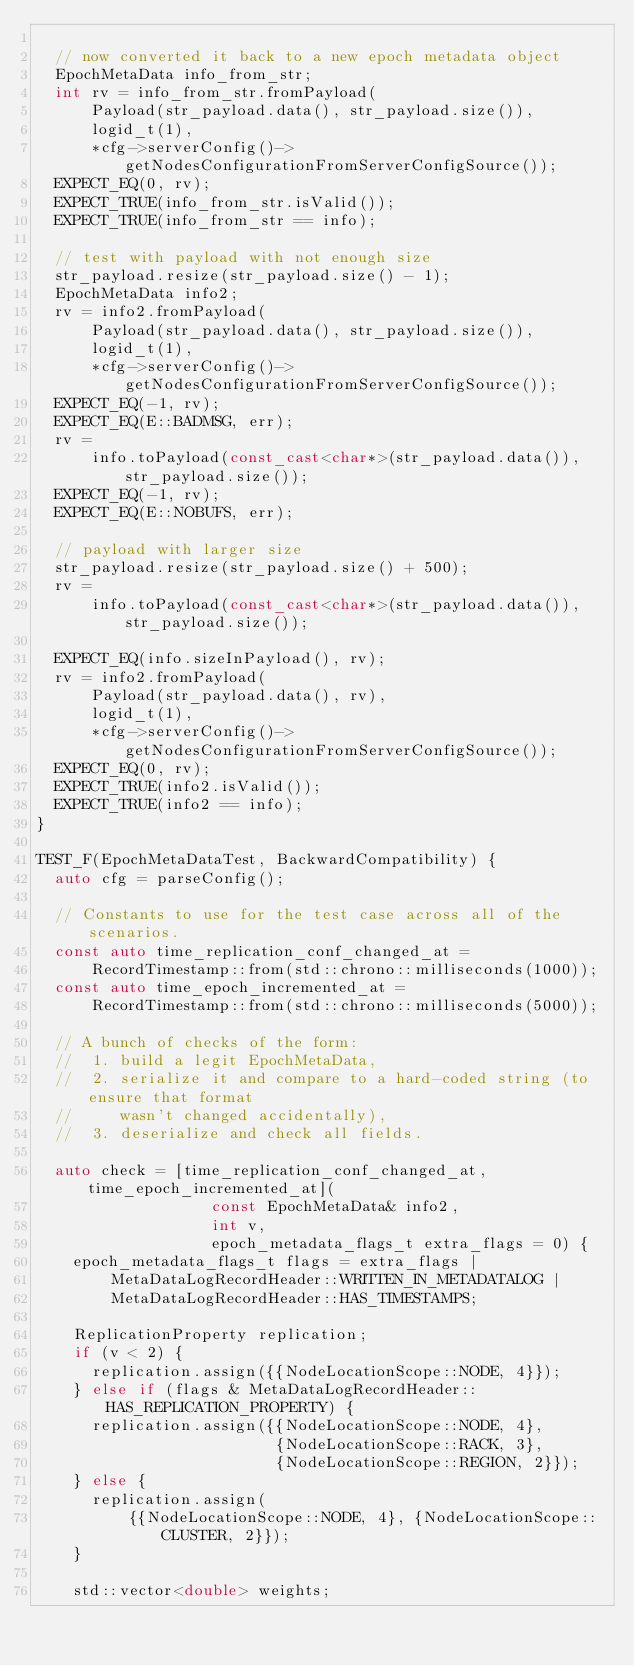Convert code to text. <code><loc_0><loc_0><loc_500><loc_500><_C++_>
  // now converted it back to a new epoch metadata object
  EpochMetaData info_from_str;
  int rv = info_from_str.fromPayload(
      Payload(str_payload.data(), str_payload.size()),
      logid_t(1),
      *cfg->serverConfig()->getNodesConfigurationFromServerConfigSource());
  EXPECT_EQ(0, rv);
  EXPECT_TRUE(info_from_str.isValid());
  EXPECT_TRUE(info_from_str == info);

  // test with payload with not enough size
  str_payload.resize(str_payload.size() - 1);
  EpochMetaData info2;
  rv = info2.fromPayload(
      Payload(str_payload.data(), str_payload.size()),
      logid_t(1),
      *cfg->serverConfig()->getNodesConfigurationFromServerConfigSource());
  EXPECT_EQ(-1, rv);
  EXPECT_EQ(E::BADMSG, err);
  rv =
      info.toPayload(const_cast<char*>(str_payload.data()), str_payload.size());
  EXPECT_EQ(-1, rv);
  EXPECT_EQ(E::NOBUFS, err);

  // payload with larger size
  str_payload.resize(str_payload.size() + 500);
  rv =
      info.toPayload(const_cast<char*>(str_payload.data()), str_payload.size());

  EXPECT_EQ(info.sizeInPayload(), rv);
  rv = info2.fromPayload(
      Payload(str_payload.data(), rv),
      logid_t(1),
      *cfg->serverConfig()->getNodesConfigurationFromServerConfigSource());
  EXPECT_EQ(0, rv);
  EXPECT_TRUE(info2.isValid());
  EXPECT_TRUE(info2 == info);
}

TEST_F(EpochMetaDataTest, BackwardCompatibility) {
  auto cfg = parseConfig();

  // Constants to use for the test case across all of the scenarios.
  const auto time_replication_conf_changed_at =
      RecordTimestamp::from(std::chrono::milliseconds(1000));
  const auto time_epoch_incremented_at =
      RecordTimestamp::from(std::chrono::milliseconds(5000));

  // A bunch of checks of the form:
  //  1. build a legit EpochMetaData,
  //  2. serialize it and compare to a hard-coded string (to ensure that format
  //     wasn't changed accidentally),
  //  3. deserialize and check all fields.

  auto check = [time_replication_conf_changed_at, time_epoch_incremented_at](
                   const EpochMetaData& info2,
                   int v,
                   epoch_metadata_flags_t extra_flags = 0) {
    epoch_metadata_flags_t flags = extra_flags |
        MetaDataLogRecordHeader::WRITTEN_IN_METADATALOG |
        MetaDataLogRecordHeader::HAS_TIMESTAMPS;

    ReplicationProperty replication;
    if (v < 2) {
      replication.assign({{NodeLocationScope::NODE, 4}});
    } else if (flags & MetaDataLogRecordHeader::HAS_REPLICATION_PROPERTY) {
      replication.assign({{NodeLocationScope::NODE, 4},
                          {NodeLocationScope::RACK, 3},
                          {NodeLocationScope::REGION, 2}});
    } else {
      replication.assign(
          {{NodeLocationScope::NODE, 4}, {NodeLocationScope::CLUSTER, 2}});
    }

    std::vector<double> weights;</code> 